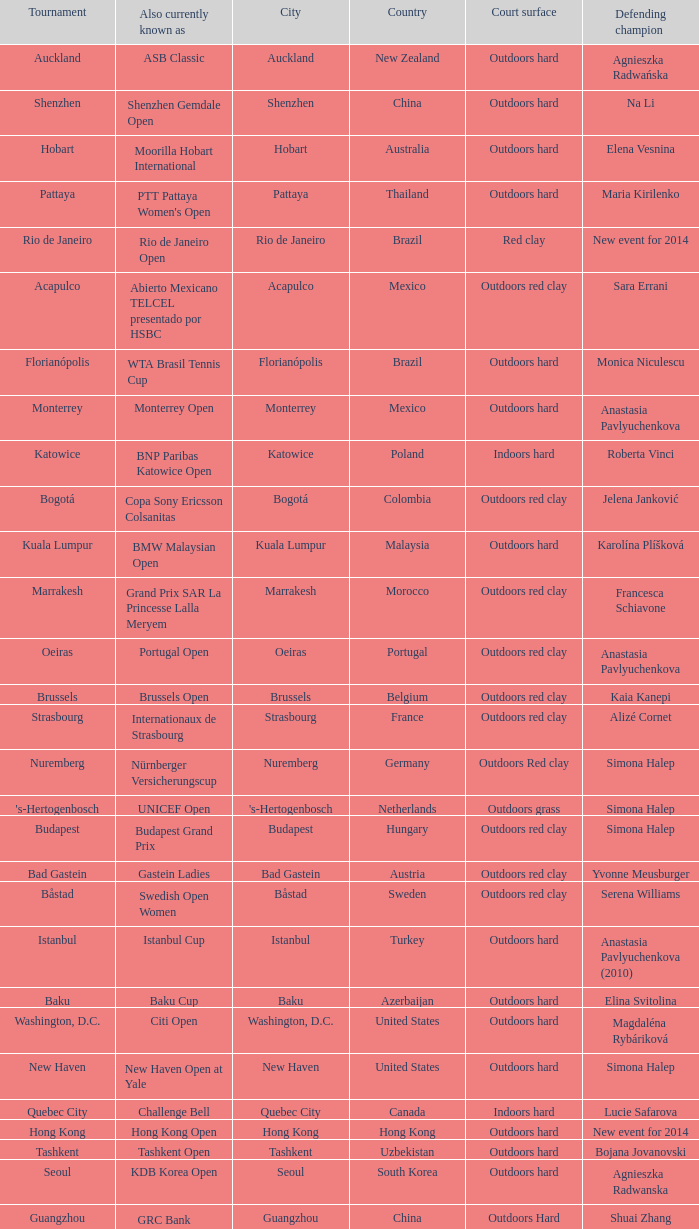What tournament is in katowice? Katowice. 